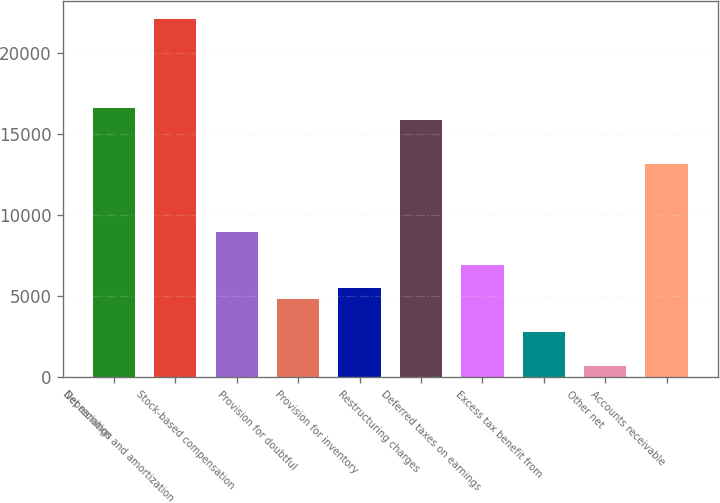<chart> <loc_0><loc_0><loc_500><loc_500><bar_chart><fcel>Net earnings<fcel>Depreciation and amortization<fcel>Stock-based compensation<fcel>Provision for doubtful<fcel>Provision for inventory<fcel>Restructuring charges<fcel>Deferred taxes on earnings<fcel>Excess tax benefit from<fcel>Other net<fcel>Accounts receivable<nl><fcel>16578<fcel>22102<fcel>8982.5<fcel>4839.5<fcel>5530<fcel>15887.5<fcel>6911<fcel>2768<fcel>696.5<fcel>13125.5<nl></chart> 